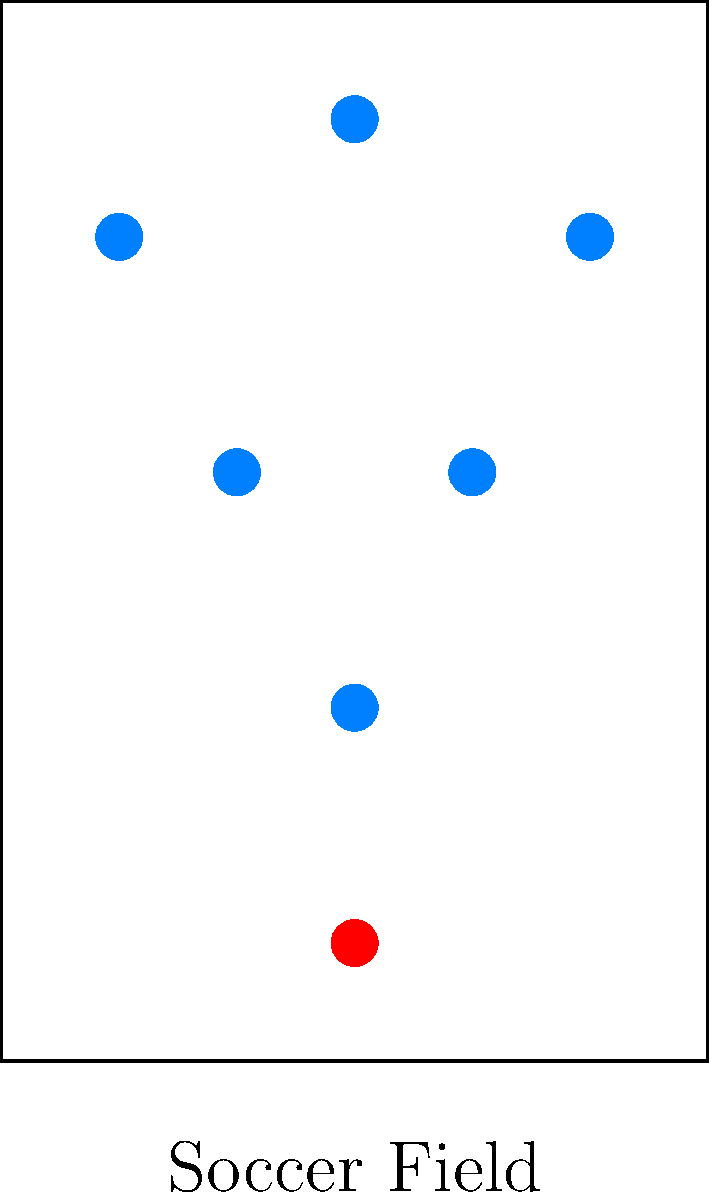Consider the soccer formation represented by the blue dots in the diagram. Which symmetry operation(s) would leave this formation unchanged?

A) Rotation by 180°
B) Reflection across the vertical axis
C) Reflection across the horizontal axis
D) Both A and B Let's analyze the symmetry of the formation step-by-step:

1) First, we need to identify the center of the formation. In this case, it's the vertical line running through the center of the field.

2) Rotation by 180°:
   If we rotate the formation 180° around the center, each player would swap positions with another player on the opposite side of the field. The overall shape would remain unchanged. This is a valid symmetry operation.

3) Reflection across the vertical axis:
   If we reflect the formation across the vertical axis (imaginary line running from top to bottom through the center), each player would mirror to the opposite side. The overall shape would remain unchanged. This is also a valid symmetry operation.

4) Reflection across the horizontal axis:
   If we reflect the formation across the horizontal axis (imaginary line running from left to right through the center), the shape would change. The two forwards would be at the back, and the defenders would be at the front. This is not a valid symmetry operation for this formation.

5) The formation possesses both 180° rotational symmetry and reflection symmetry across the vertical axis.

Therefore, both options A and B are correct symmetry operations for this formation.
Answer: D 